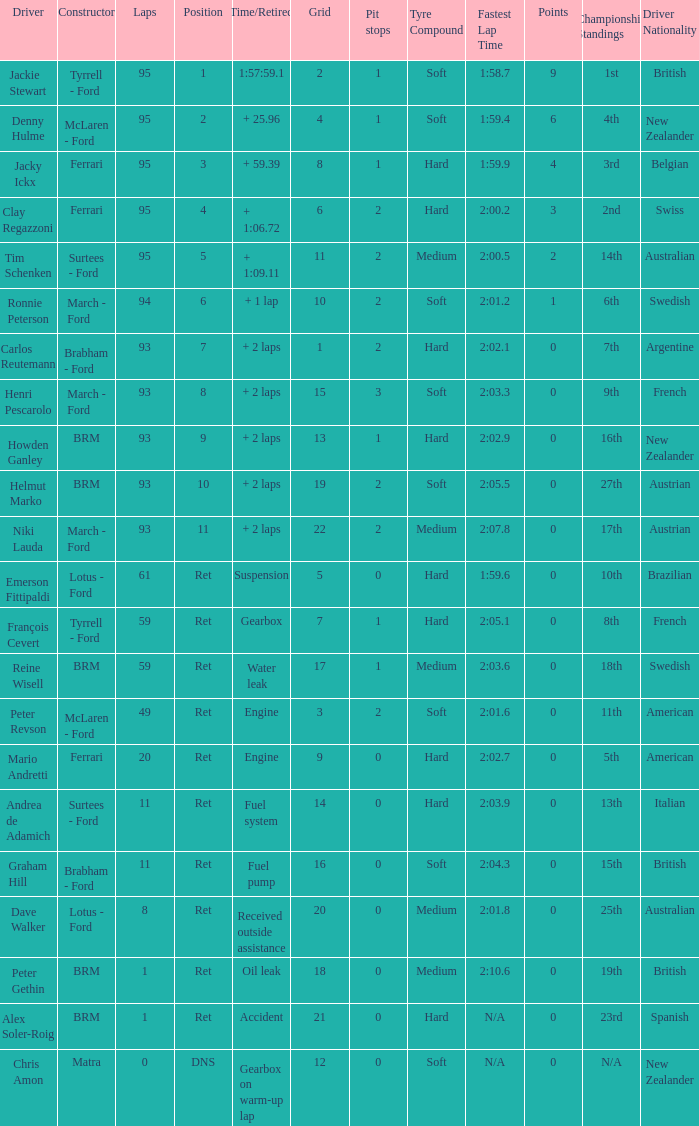What is the count of grids in dave walker's possession? 1.0. 